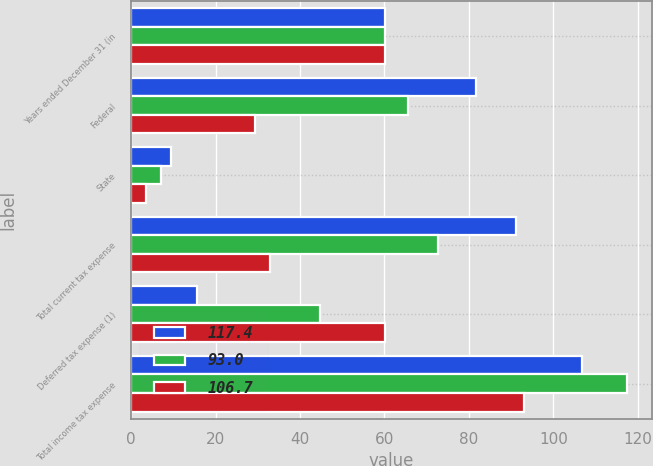<chart> <loc_0><loc_0><loc_500><loc_500><stacked_bar_chart><ecel><fcel>Years ended December 31 (in<fcel>Federal<fcel>State<fcel>Total current tax expense<fcel>Deferred tax expense (1)<fcel>Total income tax expense<nl><fcel>117.4<fcel>60.1<fcel>81.7<fcel>9.5<fcel>91.2<fcel>15.5<fcel>106.7<nl><fcel>93<fcel>60.1<fcel>65.5<fcel>7.1<fcel>72.6<fcel>44.8<fcel>117.4<nl><fcel>106.7<fcel>60.1<fcel>29.4<fcel>3.5<fcel>32.9<fcel>60.1<fcel>93<nl></chart> 